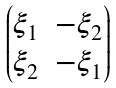Convert formula to latex. <formula><loc_0><loc_0><loc_500><loc_500>\begin{pmatrix} \xi _ { 1 } & - \xi _ { 2 } \\ \xi _ { 2 } & - \xi _ { 1 } \\ \end{pmatrix}</formula> 